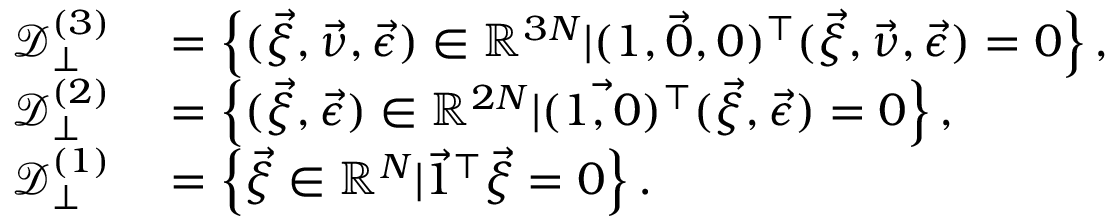Convert formula to latex. <formula><loc_0><loc_0><loc_500><loc_500>\begin{array} { r l } { \mathcal { D } _ { \perp } ^ { ( 3 ) } } & = \left \{ ( \vec { \xi } , \vec { \nu } , \vec { \epsilon } ) \in \mathbb { R } ^ { 3 N } | ( \vec { 1 , 0 , 0 } ) ^ { \top } ( \vec { \xi } , \vec { \nu } , \vec { \epsilon } ) = 0 \right \} , } \\ { \mathcal { D } _ { \perp } ^ { ( 2 ) } } & = \left \{ ( \vec { \xi } , \vec { \epsilon } ) \in \mathbb { R } ^ { 2 N } | ( \vec { 1 , 0 } ) ^ { \top } ( \vec { \xi } , \vec { \epsilon } ) = 0 \right \} , } \\ { \mathcal { D } _ { \perp } ^ { ( 1 ) } } & = \left \{ \vec { \xi } \in \mathbb { R } ^ { N } | \vec { 1 } ^ { \top } \vec { \xi } = 0 \right \} . } \end{array}</formula> 